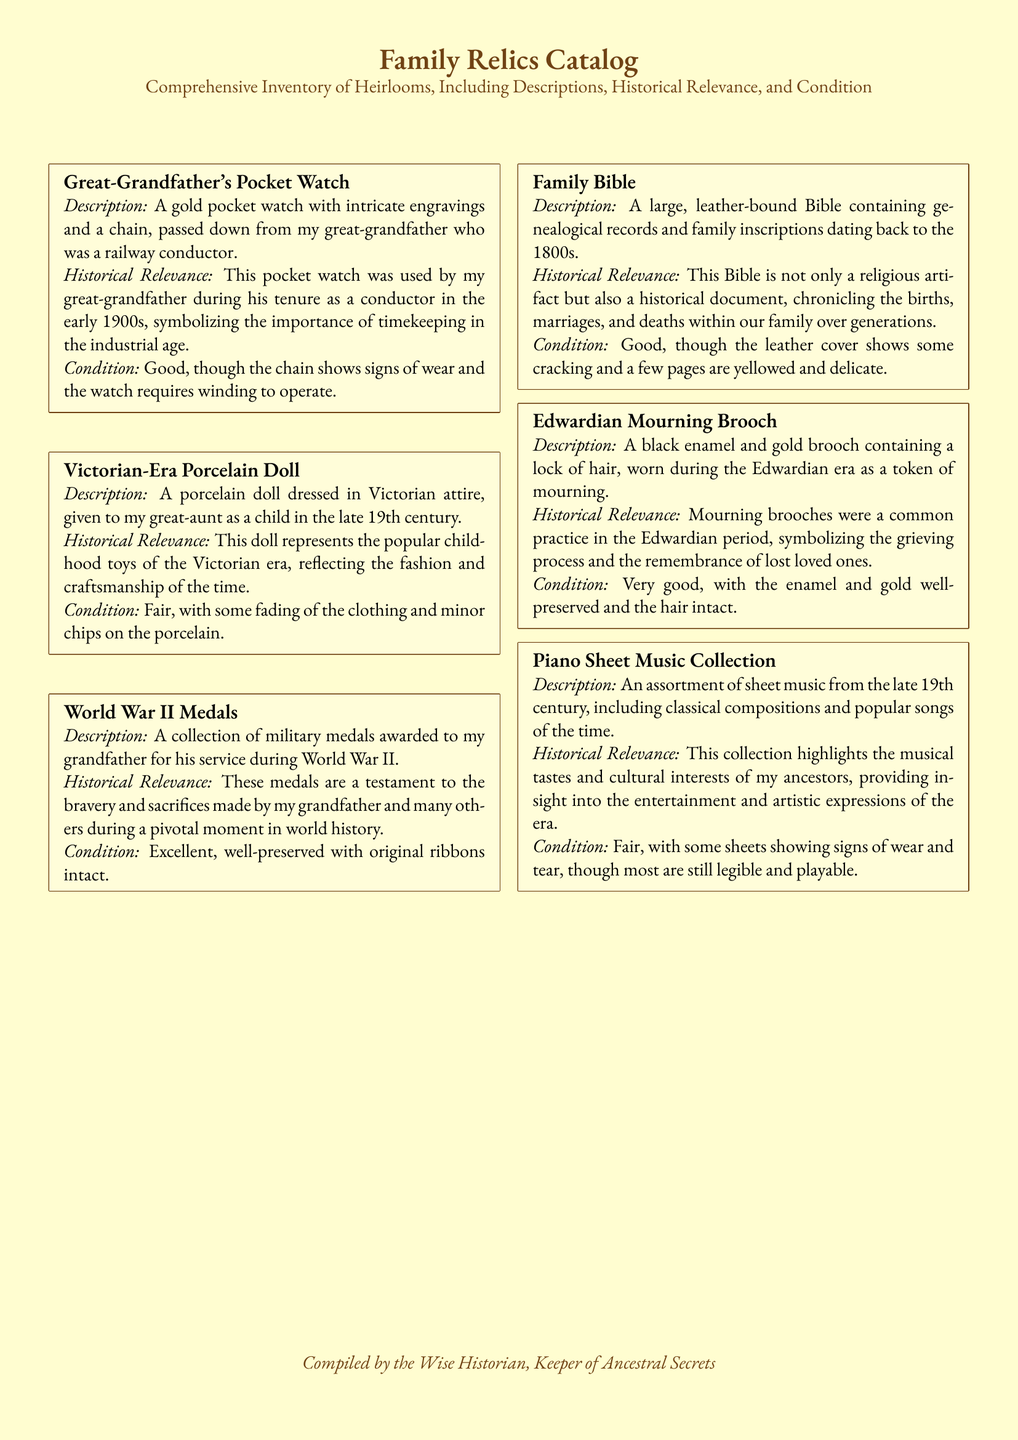What is the historical relevance of the Victorian-Era Porcelain Doll? The historical relevance provides insight into childhood toys and fashion of the Victorian era.
Answer: Popular childhood toys of the Victorian era How many medals are in the World War II collection? The document mentions a "collection" of medals but does not specify the exact number.
Answer: Collection What is the condition of the Family Bible? The description specifically states the condition of the Family Bible, mentioning some wear.
Answer: Good Who was the original owner of the Great-Grandfather's Pocket Watch? The original owner is stated clearly as my great-grandfather who was a railway conductor.
Answer: My great-grandfather What does the Edwardian Mourning Brooch contain? The document describes what the brooch includes as part of its description.
Answer: A lock of hair What era do the Piano Sheet Music come from? The document's description indicates the time period for the sheet music collection.
Answer: Late 19th century What was the main purpose of the Family Bible? The document informs us about the family history recorded in the Bible.
Answer: Genealogical records What kind of materials does the Edwardian Mourning Brooch use? The materials used in the brooch are specified in the description section.
Answer: Black enamel and gold 